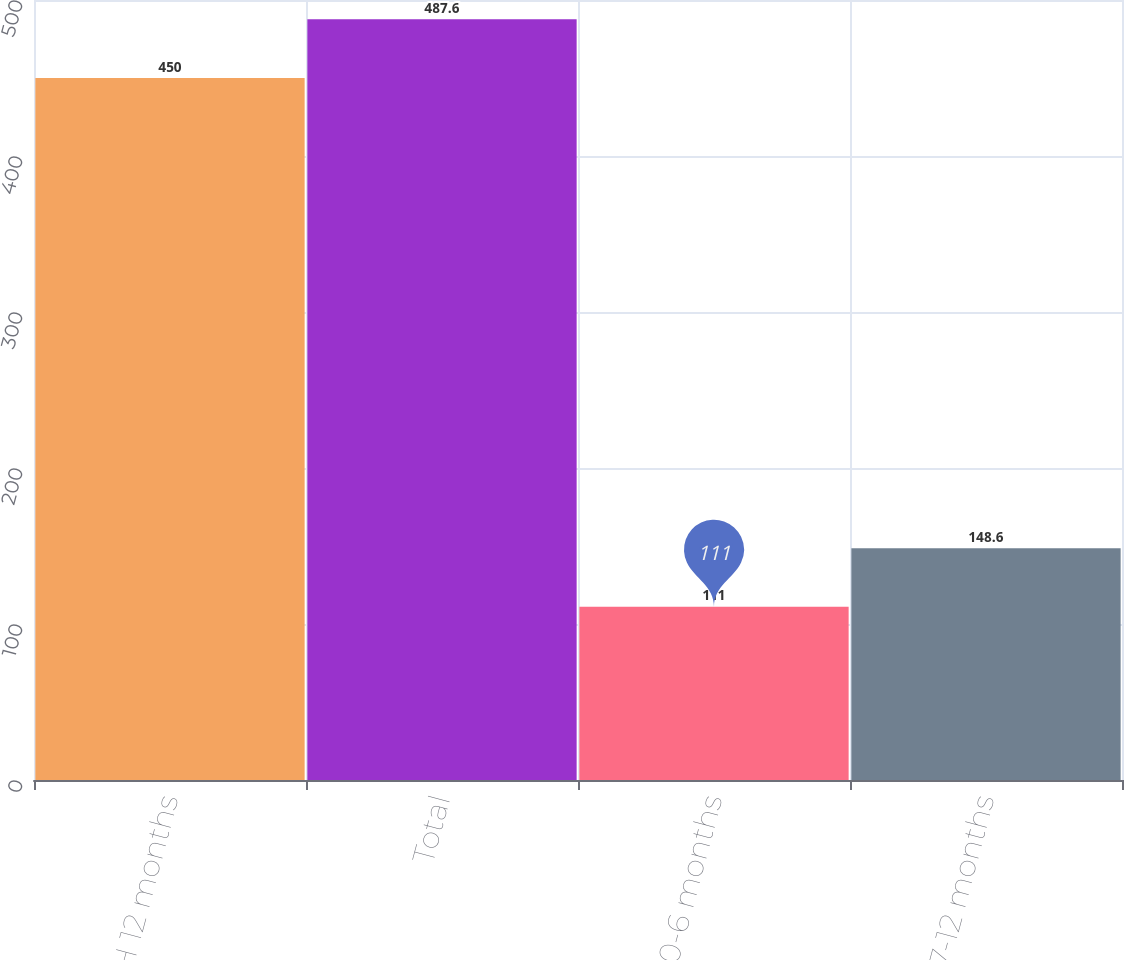Convert chart to OTSL. <chart><loc_0><loc_0><loc_500><loc_500><bar_chart><fcel>H 12 months<fcel>Total<fcel>0-6 months<fcel>7-12 months<nl><fcel>450<fcel>487.6<fcel>111<fcel>148.6<nl></chart> 